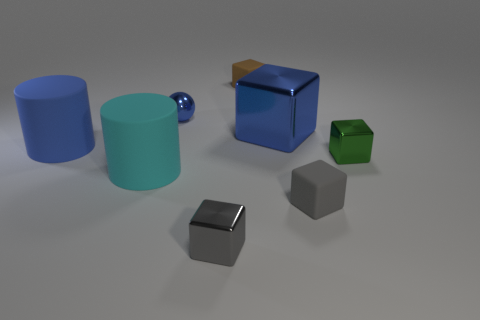Subtract all small green metal cubes. How many cubes are left? 4 Subtract all gray cubes. How many cubes are left? 3 Add 2 blue blocks. How many objects exist? 10 Subtract all spheres. How many objects are left? 7 Add 1 red metal blocks. How many red metal blocks exist? 1 Subtract 0 purple balls. How many objects are left? 8 Subtract 4 blocks. How many blocks are left? 1 Subtract all cyan cubes. Subtract all yellow cylinders. How many cubes are left? 5 Subtract all purple blocks. How many purple spheres are left? 0 Subtract all brown things. Subtract all small metal things. How many objects are left? 4 